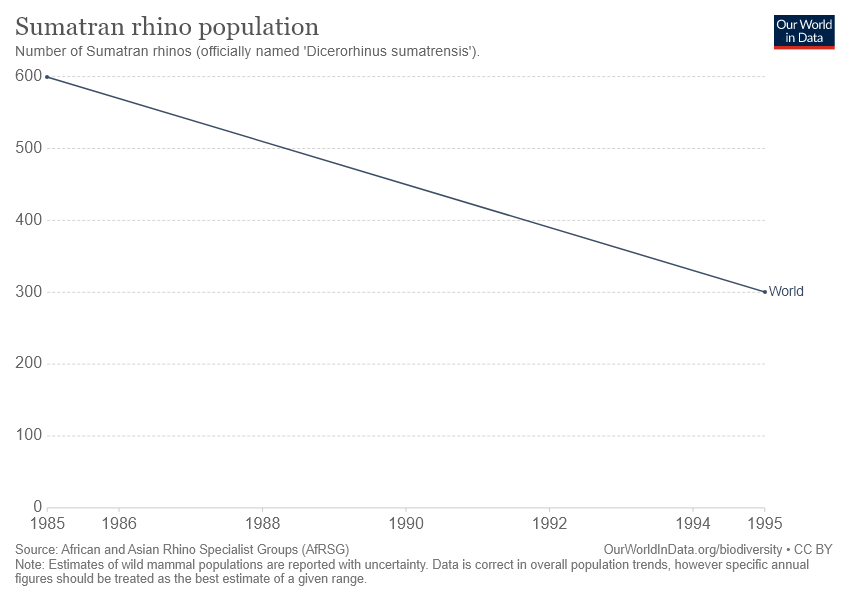Specify some key components in this picture. In 1985, the average number of Sumatran rhinos was approximately 450, and by 1995, that number had increased slightly to around 500. In 1995, the number of Sumatran rhinos was at its lowest point in the world. 